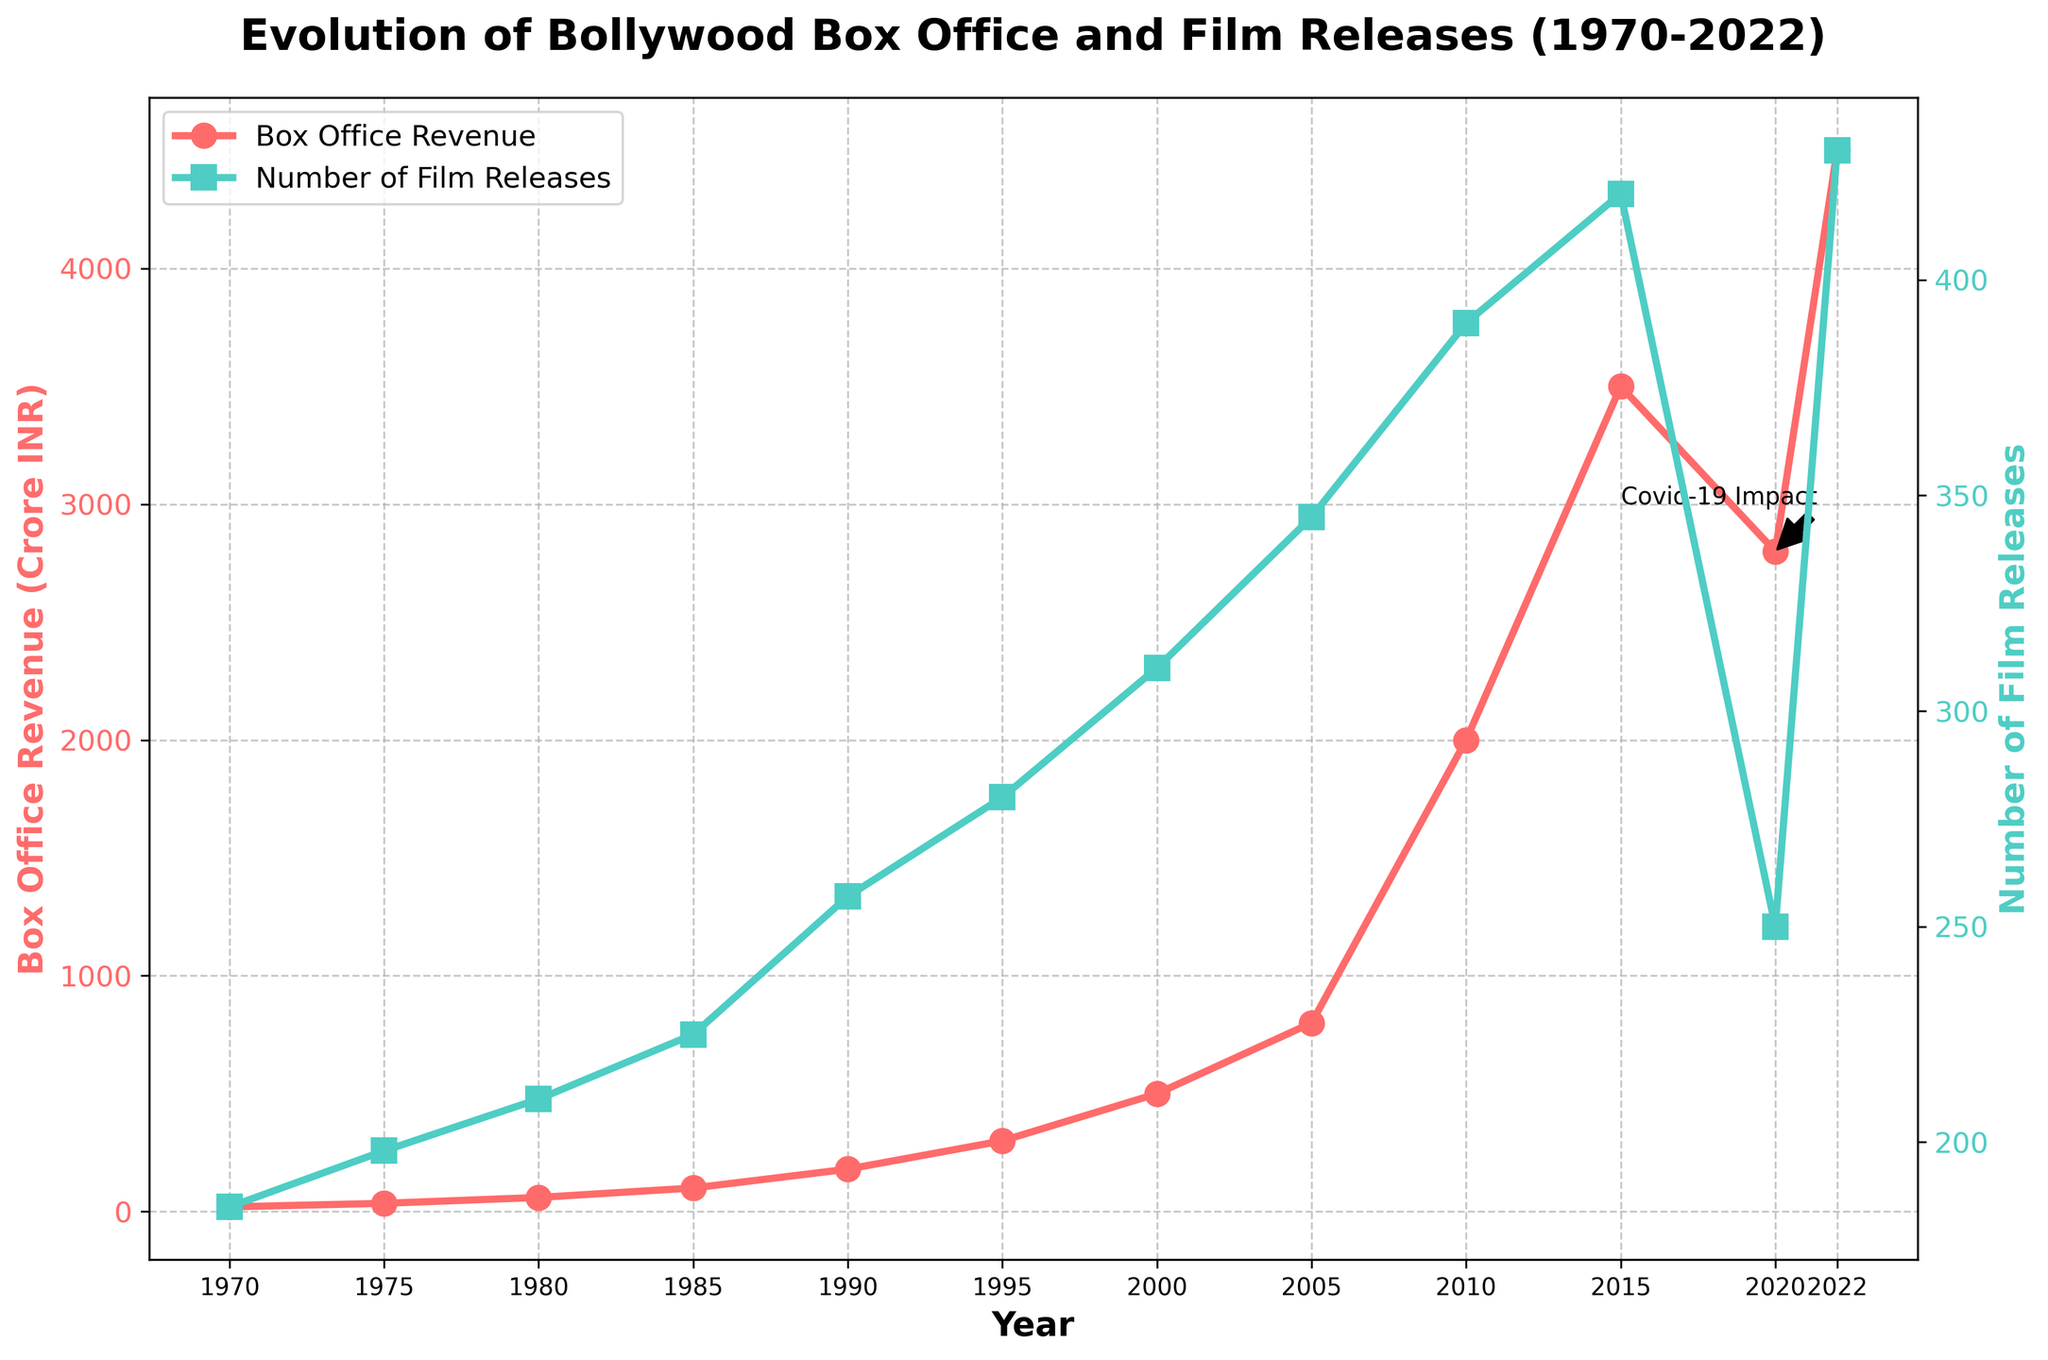**1.** What was the Box Office Revenue in 1995? According to the figure, the Box Office Revenue in 1995 can be identified by locating the corresponding point on the red line graphed across the years, where it intersects the y-axis representing revenue.
Answer: 300 Crore INR **2.** How many films were released in 2000 compared to 1980? To find out the number of film releases in 2000 and 1980, refer to the turquoise line plotted in the figure and compare the y-axis values at those years.
Answer: 310 (2000), 210 (1980) **3.** During which years did the Box Office Revenue experience a rapid increase? The rapid increase can be recognized by the steep sections of the red line. Notable periods include between 2000 to 2010 and 2010 to 2015.
Answer: 2000-2010, 2010-2015 **4.** In which year did the number of film releases drop significantly compared to the previous year? By observing the turquoise line, there is a noticeable drop around 2020, likely due to the Covid-19 impact annotated on the graph.
Answer: 2020 **5.** Compare the trend of Box Office Revenue and Number of Film Releases from 2000 to 2022. From 2000 to 2022, Box Office Revenue (red line) shows a sharp increase, particularly steep from 2000 to 2010 and 2022. The number of film releases (turquoise line) generally increases with a sharp dip in 2020, but recovers in 2022.
Answer: Rapid Revenue Increase, Stable Release Increase with 2020 Dip **6.** What is the approximate average annual increase in Box Office Revenue from 1970 to 1990? To calculate the average annual increase for this period, subtract the revenue in 1970 (20 Crore INR) from the revenue in 1990 (180 Crore INR), then divide by the number of years (20).
Answer: (180-20) / 20 = 8 Crore INR per year **7.** Did the number of film releases ever decrease from one recorded point to another? Examining the Number of Film Releases values, there is only one instance, from 2015 (420 films) to 2020 (250 films), indicating a decrease.
Answer: Yes, from 2015 to 2020 **8.** Which year is annotated for the impact of Covid-19 on Box Office Revenue? Refer to the annotation on the chart stating "Covid-19 Impact" near the year 2020, highlighted by an arrow.
Answer: 2020 **9.** What are the patterns observed in Box Office Revenue and Number of Film Releases in terms of visual color and markers used? The red line with circle markers represents Box Office Revenue, while the turquoise line with square markers depicts the Number of Film Releases.
Answer: Red circles for Revenue, Turquoise squares for Releases **10.** Which year had the highest number of film releases, and what was the count? By looking at the peak of the turquoise line, the highest number is recorded in the year 2022.
Answer: 2022, 430 films 